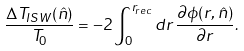Convert formula to latex. <formula><loc_0><loc_0><loc_500><loc_500>\frac { \Delta T _ { I S W } ( \hat { n } ) } { T _ { 0 } } = - 2 \int _ { 0 } ^ { r _ { r e c } } d r \, \frac { \partial \phi ( r , \hat { n } ) } { \partial r } .</formula> 